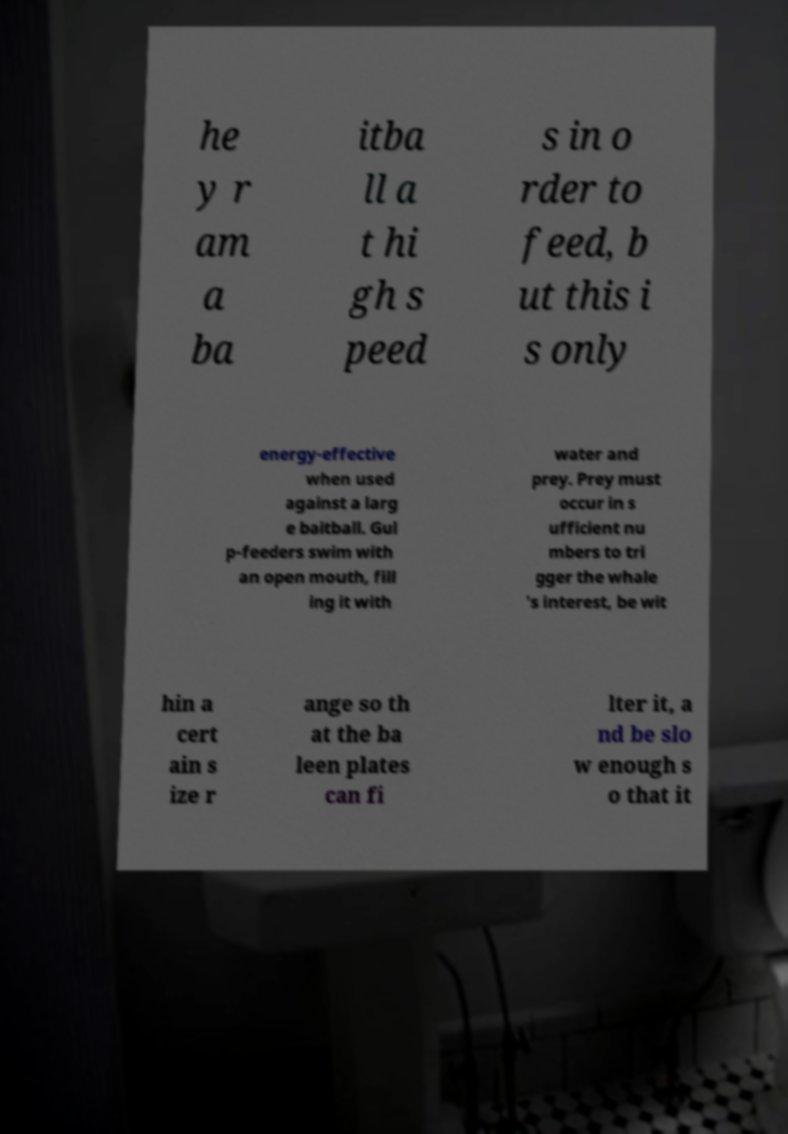Could you assist in decoding the text presented in this image and type it out clearly? he y r am a ba itba ll a t hi gh s peed s in o rder to feed, b ut this i s only energy-effective when used against a larg e baitball. Gul p-feeders swim with an open mouth, fill ing it with water and prey. Prey must occur in s ufficient nu mbers to tri gger the whale 's interest, be wit hin a cert ain s ize r ange so th at the ba leen plates can fi lter it, a nd be slo w enough s o that it 